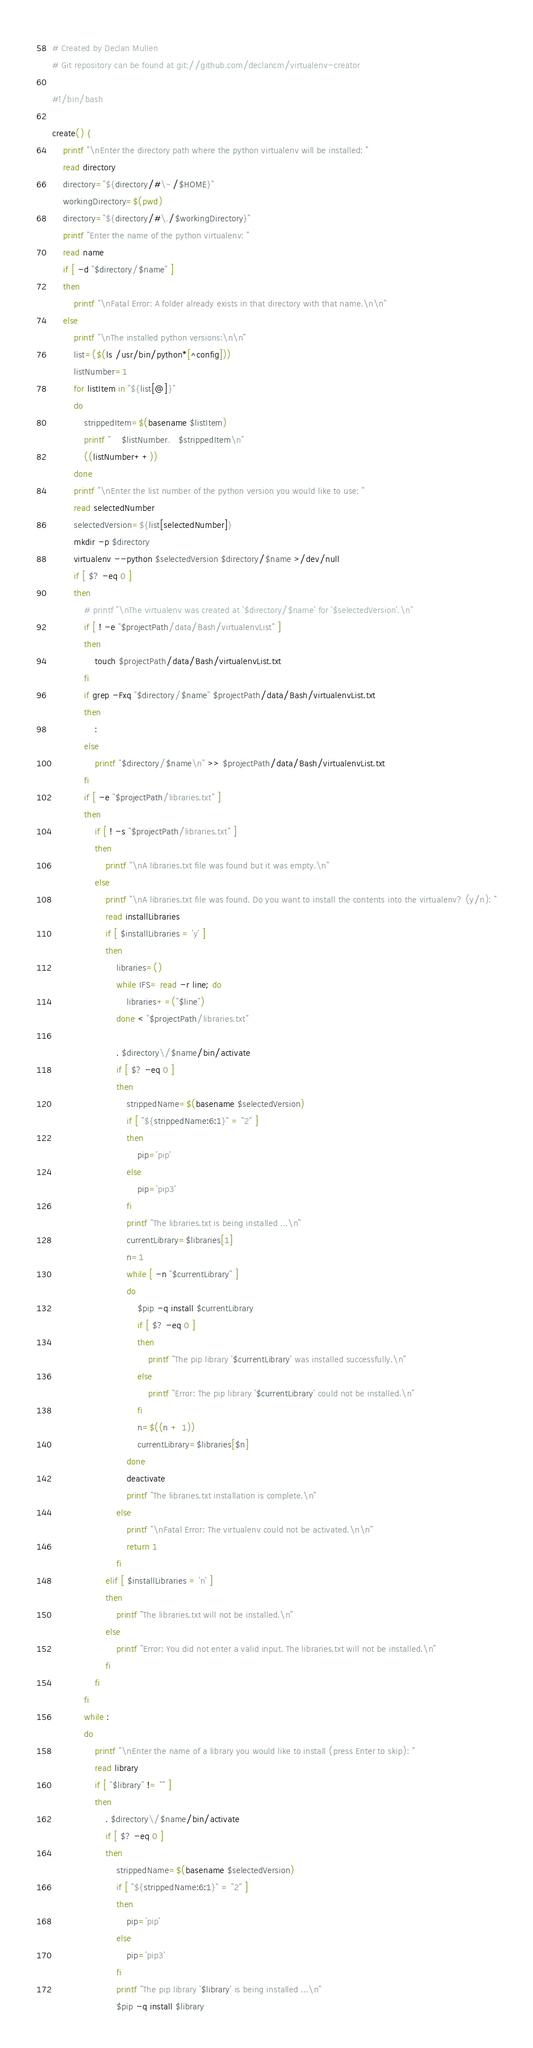Convert code to text. <code><loc_0><loc_0><loc_500><loc_500><_Bash_># Created by Declan Mullen
# Git repository can be found at git://github.com/declancm/virtualenv-creator

#!/bin/bash

create() {
    printf "\nEnter the directory path where the python virtualenv will be installed: "
    read directory
    directory="${directory/#\~/$HOME}"
    workingDirectory=$(pwd)
    directory="${directory/#\./$workingDirectory}"
    printf "Enter the name of the python virtualenv: "
    read name
    if [ -d "$directory/$name" ]
    then
        printf "\nFatal Error: A folder already exists in that directory with that name.\n\n"
    else
        printf "\nThe installed python versions:\n\n"
        list=($(ls /usr/bin/python*[^config]))
        listNumber=1
        for listItem in "${list[@]}"
        do
            strippedItem=$(basename $listItem)
            printf "    $listNumber.   $strippedItem\n"
            ((listNumber++))
        done
        printf "\nEnter the list number of the python version you would like to use: "
        read selectedNumber
        selectedVersion=${list[selectedNumber]}
        mkdir -p $directory
        virtualenv --python $selectedVersion $directory/$name >/dev/null
        if [ $? -eq 0 ]
        then
            # printf "\nThe virtualenv was created at '$directory/$name' for '$selectedVersion'.\n"
            if [ ! -e "$projectPath/data/Bash/virtualenvList" ]
            then
                touch $projectPath/data/Bash/virtualenvList.txt
            fi
            if grep -Fxq "$directory/$name" $projectPath/data/Bash/virtualenvList.txt
            then
                :
            else
                printf "$directory/$name\n" >> $projectPath/data/Bash/virtualenvList.txt
            fi
            if [ -e "$projectPath/libraries.txt" ]
            then
                if [ ! -s "$projectPath/libraries.txt" ]
                then
                    printf "\nA libraries.txt file was found but it was empty.\n"
                else
                    printf "\nA libraries.txt file was found. Do you want to install the contents into the virtualenv? (y/n): "
                    read installLibraries
                    if [ $installLibraries = 'y' ]
                    then
                        libraries=()
                        while IFS= read -r line; do
                            libraries+=("$line")
                        done < "$projectPath/libraries.txt"

                        . $directory\/$name/bin/activate
                        if [ $? -eq 0 ]
                        then
                            strippedName=$(basename $selectedVersion)
                            if [ "${strippedName:6:1}" = "2" ]
                            then
                                pip='pip'
                            else
                                pip='pip3'
                            fi
                            printf "The libraries.txt is being installed ...\n"
                            currentLibrary=$libraries[1]
                            n=1
                            while [ -n "$currentLibrary" ]
                            do
                                $pip -q install $currentLibrary
                                if [ $? -eq 0 ]
                                then
                                    printf "The pip library '$currentLibrary' was installed successfully.\n"
                                else
                                    printf "Error: The pip library '$currentLibrary' could not be installed.\n"
                                fi
                                n=$((n + 1))
                                currentLibrary=$libraries[$n]
                            done
                            deactivate
                            printf "The libraries.txt installation is complete.\n"
                        else
                            printf "\nFatal Error: The virtualenv could not be activated.\n\n"
                            return 1
                        fi
                    elif [ $installLibraries = 'n' ]
                    then
                        printf "The libraries.txt will not be installed.\n"
                    else
                        printf "Error: You did not enter a valid input. The libraries.txt will not be installed.\n"
                    fi
                fi
            fi
            while :
            do
                printf "\nEnter the name of a library you would like to install (press Enter to skip): "
                read library
                if [ "$library" != "" ]
                then
                    . $directory\/$name/bin/activate
                    if [ $? -eq 0 ]
                    then
                        strippedName=$(basename $selectedVersion)
                        if [ "${strippedName:6:1}" = "2" ]
                        then
                            pip='pip'
                        else
                            pip='pip3'
                        fi
                        printf "The pip library '$library' is being installed ...\n"
                        $pip -q install $library</code> 